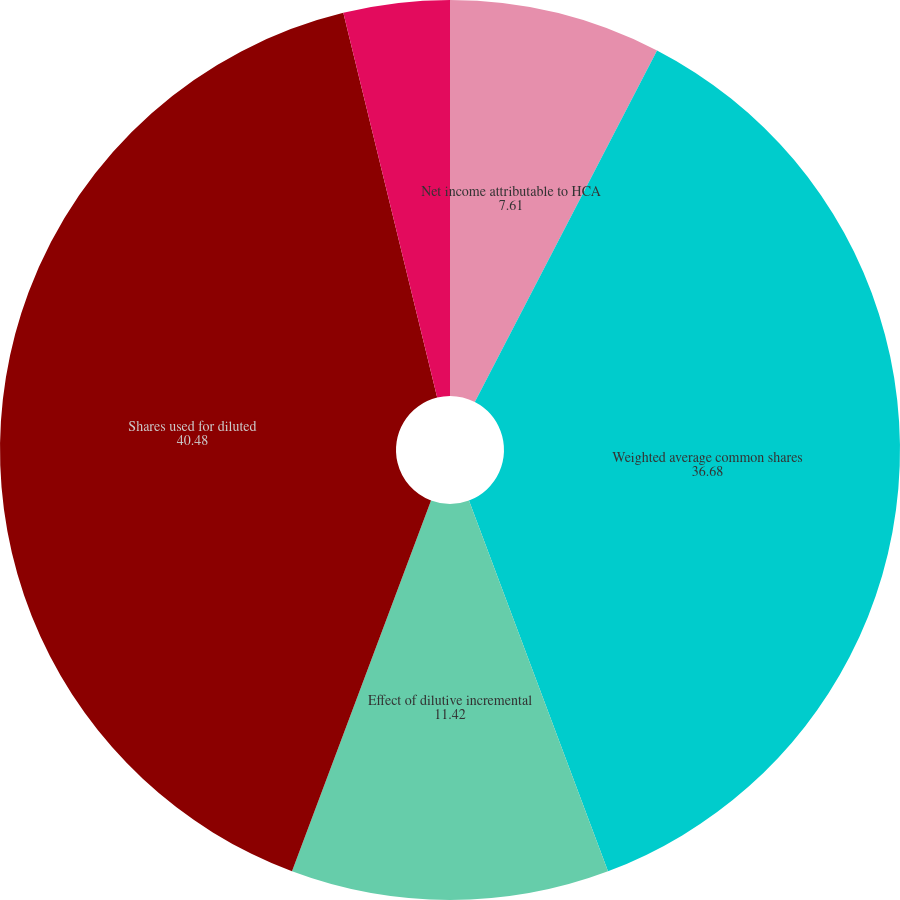Convert chart to OTSL. <chart><loc_0><loc_0><loc_500><loc_500><pie_chart><fcel>Net income attributable to HCA<fcel>Weighted average common shares<fcel>Effect of dilutive incremental<fcel>Shares used for diluted<fcel>Basic earnings per share<fcel>Diluted earnings per share<nl><fcel>7.61%<fcel>36.68%<fcel>11.42%<fcel>40.48%<fcel>3.81%<fcel>0.0%<nl></chart> 